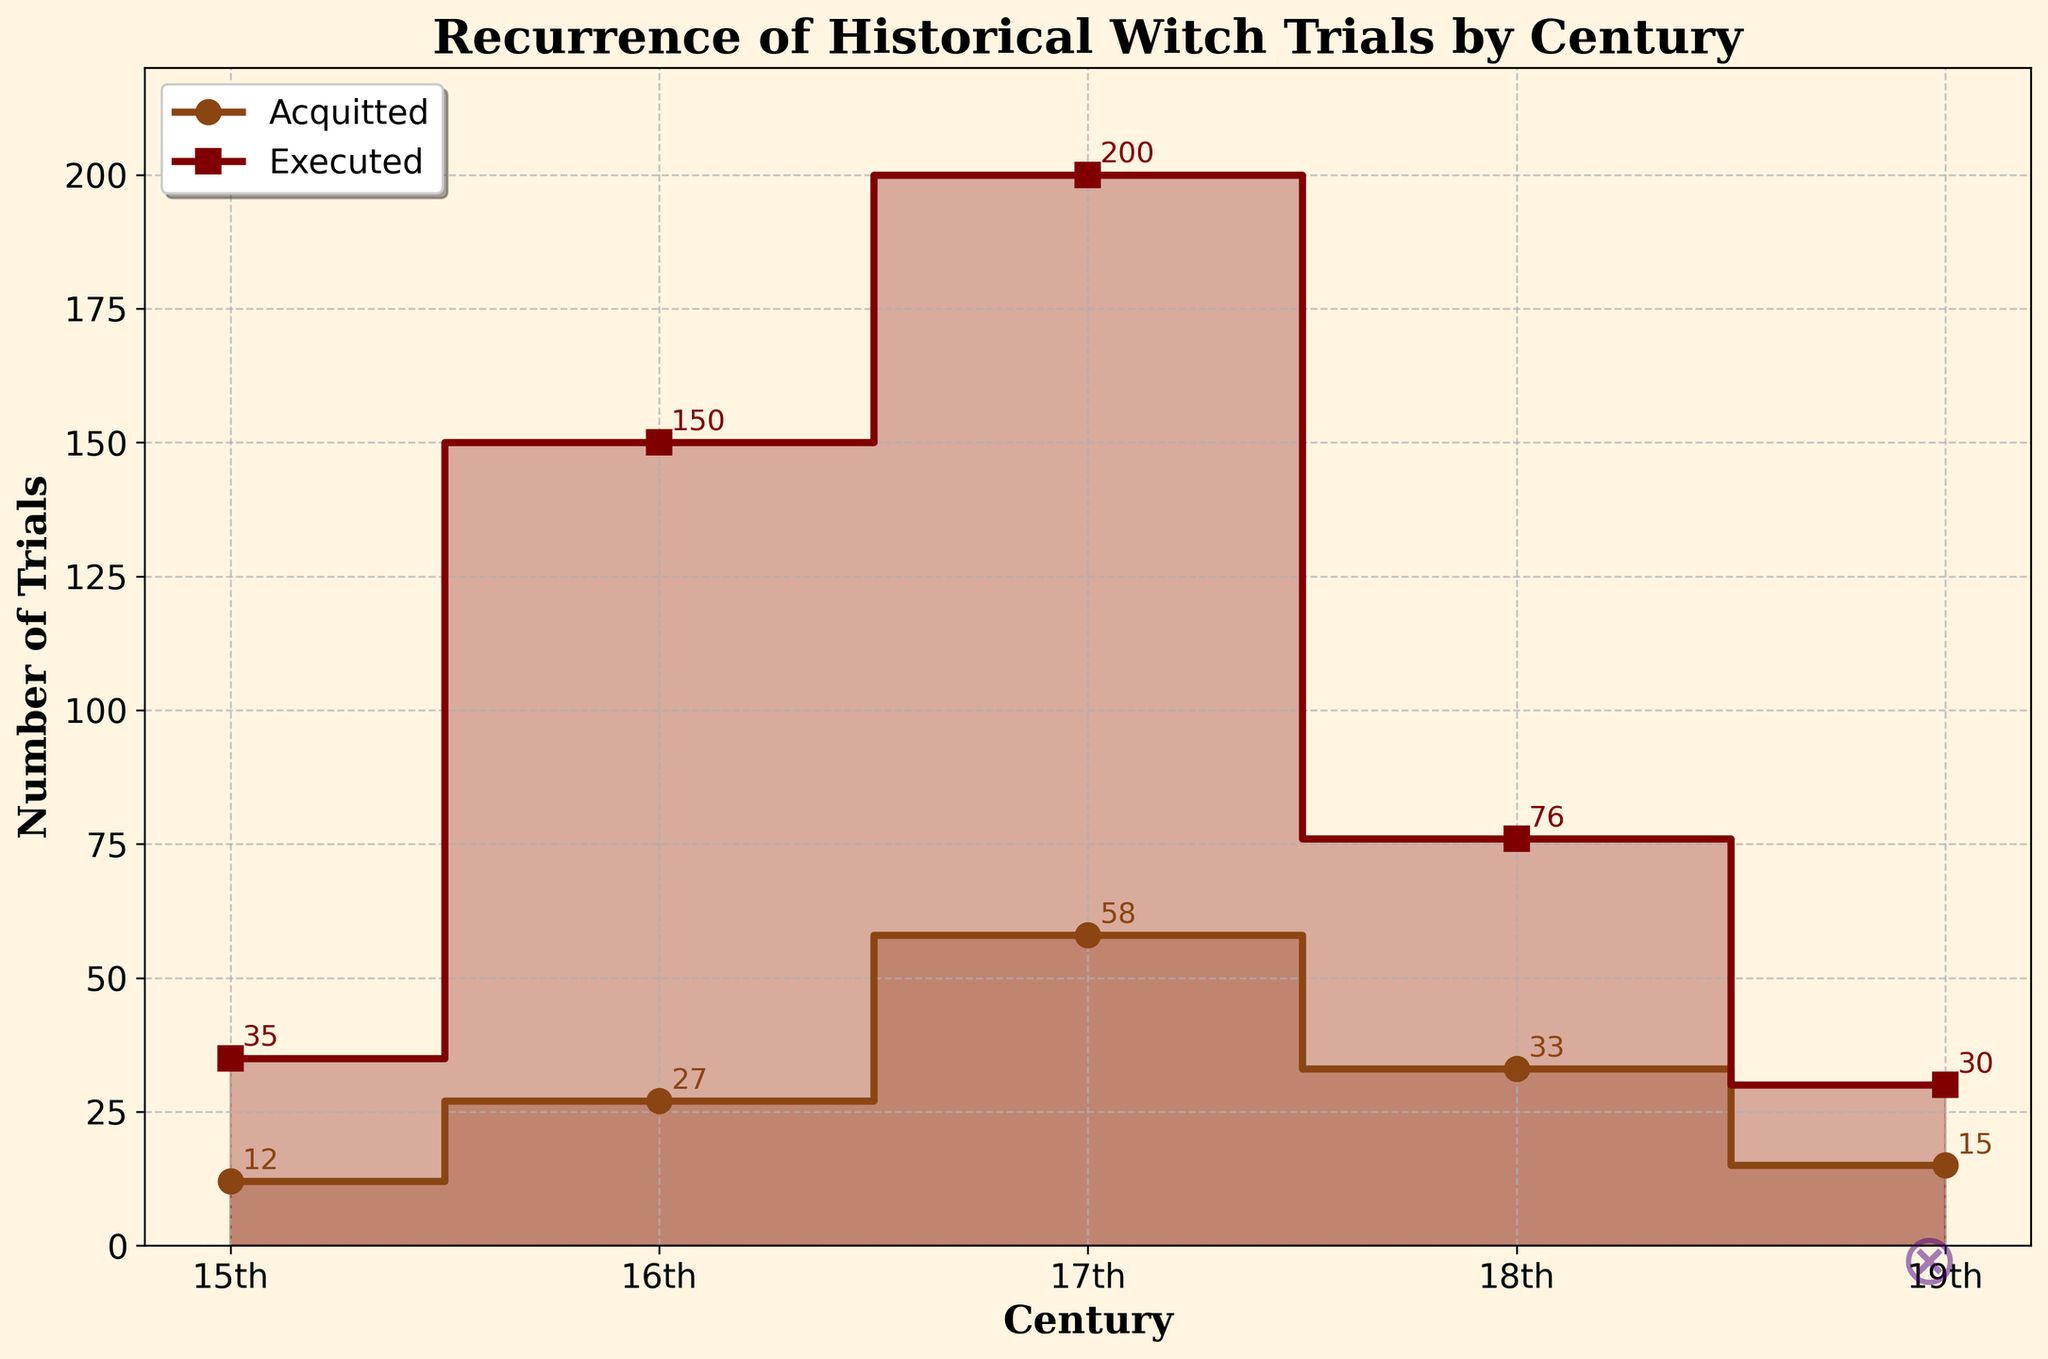Which century had the highest number of executed trials for witchcraft? The 17th century shows the highest number of executed trials, with a peak at 200, which is the highest point for the 'Executed' series on the plot.
Answer: 17th century What is the total number of acquitted trials across all centuries? To find the total number of acquitted trials, add the values for each century: 12 (15th) + 27 (16th) + 58 (17th) + 33 (18th) + 15 (19th) = 145.
Answer: 145 Which century saw a decrease in the number of executed trials compared to the previous century? The plot shows a decrease in executed trials from the 17th century (200 executed trials) to the 18th century (76 executed trials), marking a significant drop.
Answer: 18th century How does the number of acquitted trials in the 16th century compare to those in the 18th century? The plot indicates 27 acquitted trials in the 16th century and 33 in the 18th century. Comparing these, the 18th century has 6 more acquitted trials than the 16th century.
Answer: 18th century has more What is the difference in the number of executed trials between the 15th and 16th centuries? The number of executed trials in the 15th century is 35, and in the 16th century, it is 150. Subtracting these: 150 - 35 = 115.
Answer: 115 Which outcome shows a consistently increasing trend from the 15th to the 17th century? The 'Executed' outcome shows a consistent increase from 35 (15th century) to 150 (16th century), peaking at 200 (17th century).
Answer: Executed What is the average number of acquitted trials per century? To find the average, sum the number of acquitted trials across all centuries (145) and divide by the number of centuries (5): 145 / 5 = 29.
Answer: 29 Is there any century where the number of acquitted and executed trials are numerically close? In the 19th century, the number of acquitted trials (15) and executed trials (30) are relatively close, with a difference of 15.
Answer: 19th century What trend can be observed in the number of executed trials after the 17th century? The plot shows a declining trend in the number of executed trials after the 17th century, with numbers dropping from 200 (17th century) to 76 (18th century) and further to 30 (19th century).
Answer: Declining trend Which century had the lowest number of acquitted trials, and what was that number? The plot shows the 15th century had the lowest number of acquitted trials with 12.
Answer: 15th century, 12 